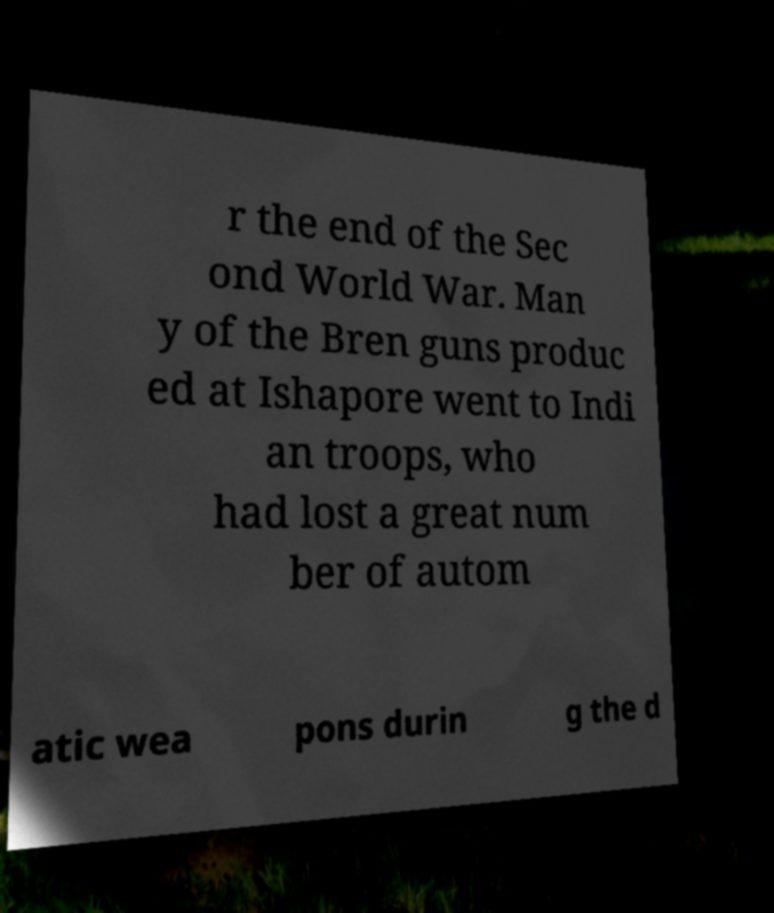Could you extract and type out the text from this image? r the end of the Sec ond World War. Man y of the Bren guns produc ed at Ishapore went to Indi an troops, who had lost a great num ber of autom atic wea pons durin g the d 